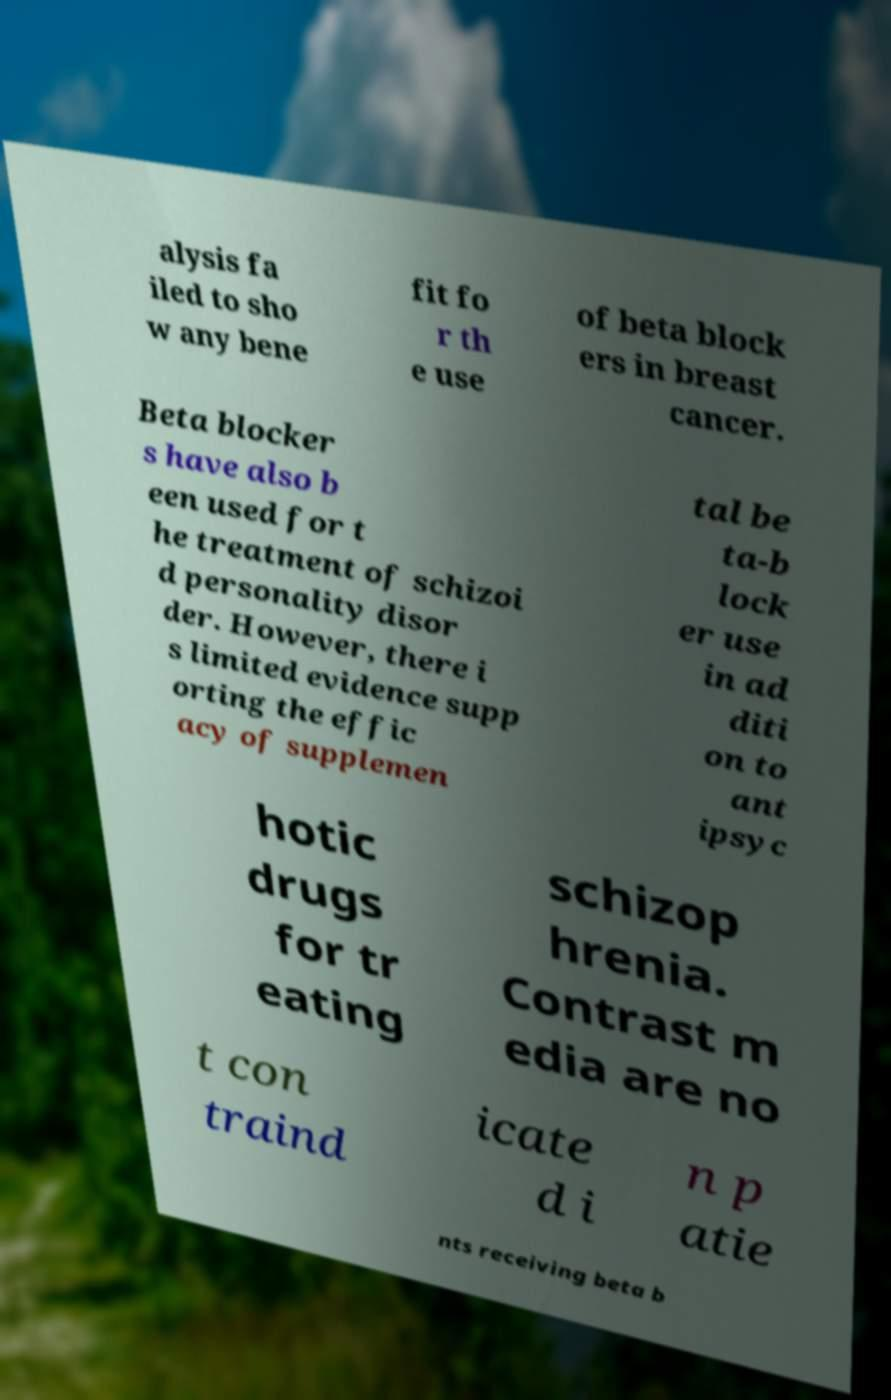Can you read and provide the text displayed in the image?This photo seems to have some interesting text. Can you extract and type it out for me? alysis fa iled to sho w any bene fit fo r th e use of beta block ers in breast cancer. Beta blocker s have also b een used for t he treatment of schizoi d personality disor der. However, there i s limited evidence supp orting the effic acy of supplemen tal be ta-b lock er use in ad diti on to ant ipsyc hotic drugs for tr eating schizop hrenia. Contrast m edia are no t con traind icate d i n p atie nts receiving beta b 